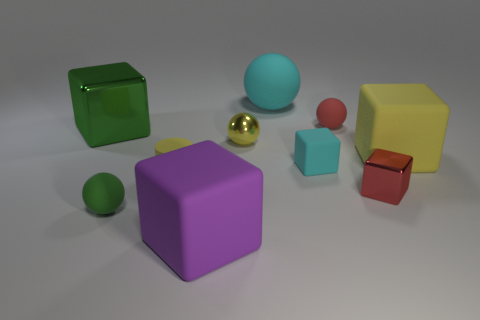Subtract all tiny cyan blocks. How many blocks are left? 4 Subtract all green blocks. How many blocks are left? 4 Subtract all gray blocks. Subtract all cyan balls. How many blocks are left? 5 Subtract all cylinders. How many objects are left? 9 Subtract all yellow things. Subtract all cyan cubes. How many objects are left? 6 Add 8 purple matte objects. How many purple matte objects are left? 9 Add 3 tiny green matte cylinders. How many tiny green matte cylinders exist? 3 Subtract 0 blue balls. How many objects are left? 10 